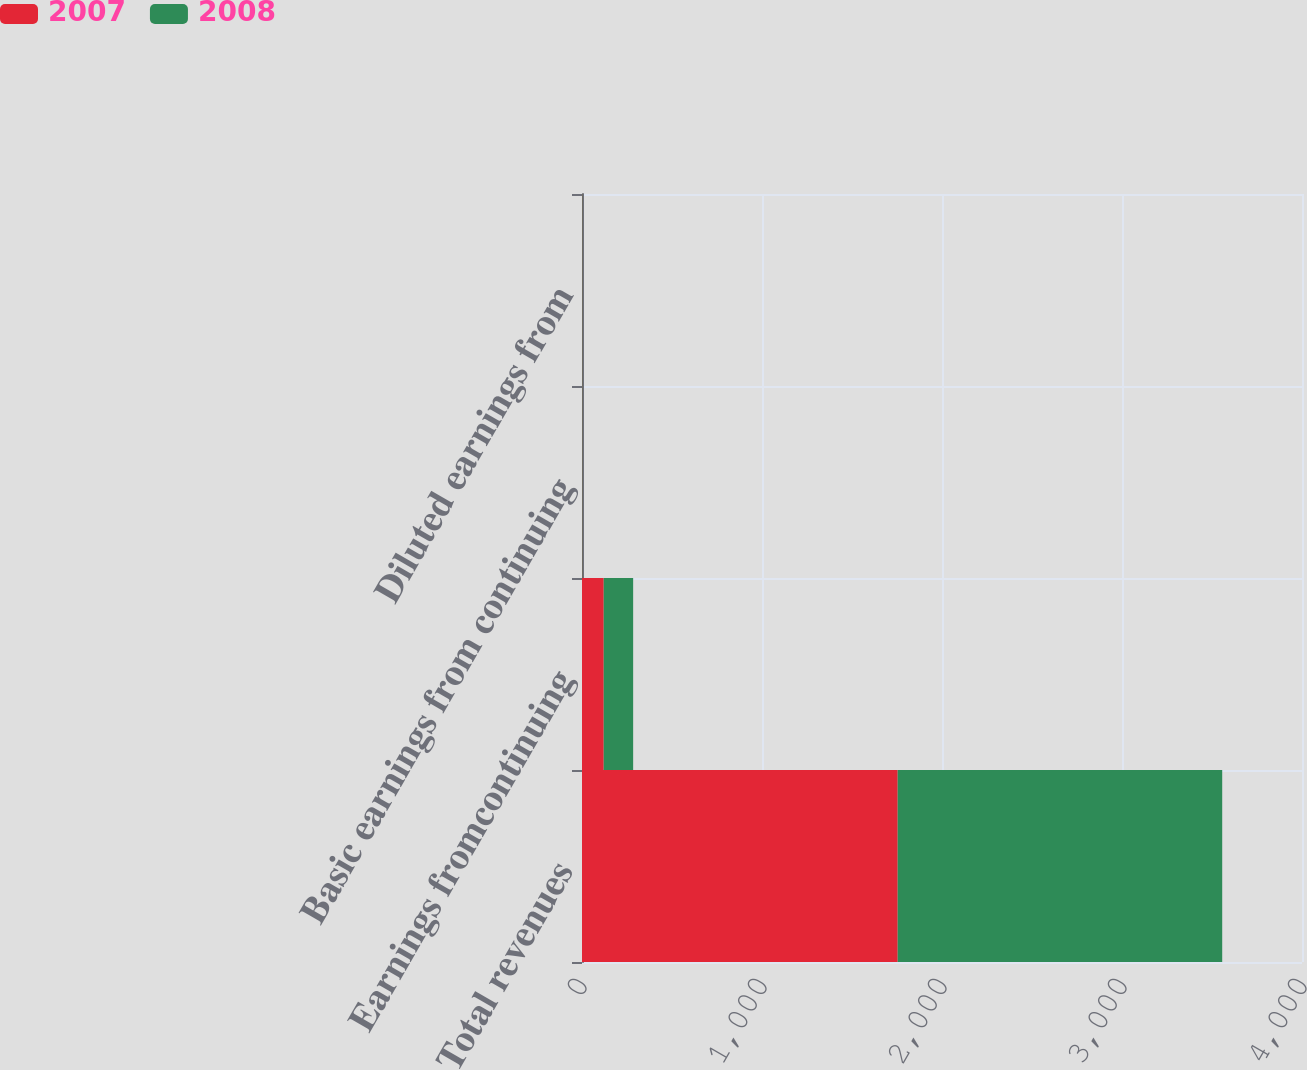<chart> <loc_0><loc_0><loc_500><loc_500><stacked_bar_chart><ecel><fcel>Total revenues<fcel>Earnings fromcontinuing<fcel>Basic earnings from continuing<fcel>Diluted earnings from<nl><fcel>2007<fcel>1753.9<fcel>120.7<fcel>1.26<fcel>1.26<nl><fcel>2008<fcel>1802.8<fcel>163.5<fcel>1.66<fcel>1.64<nl></chart> 